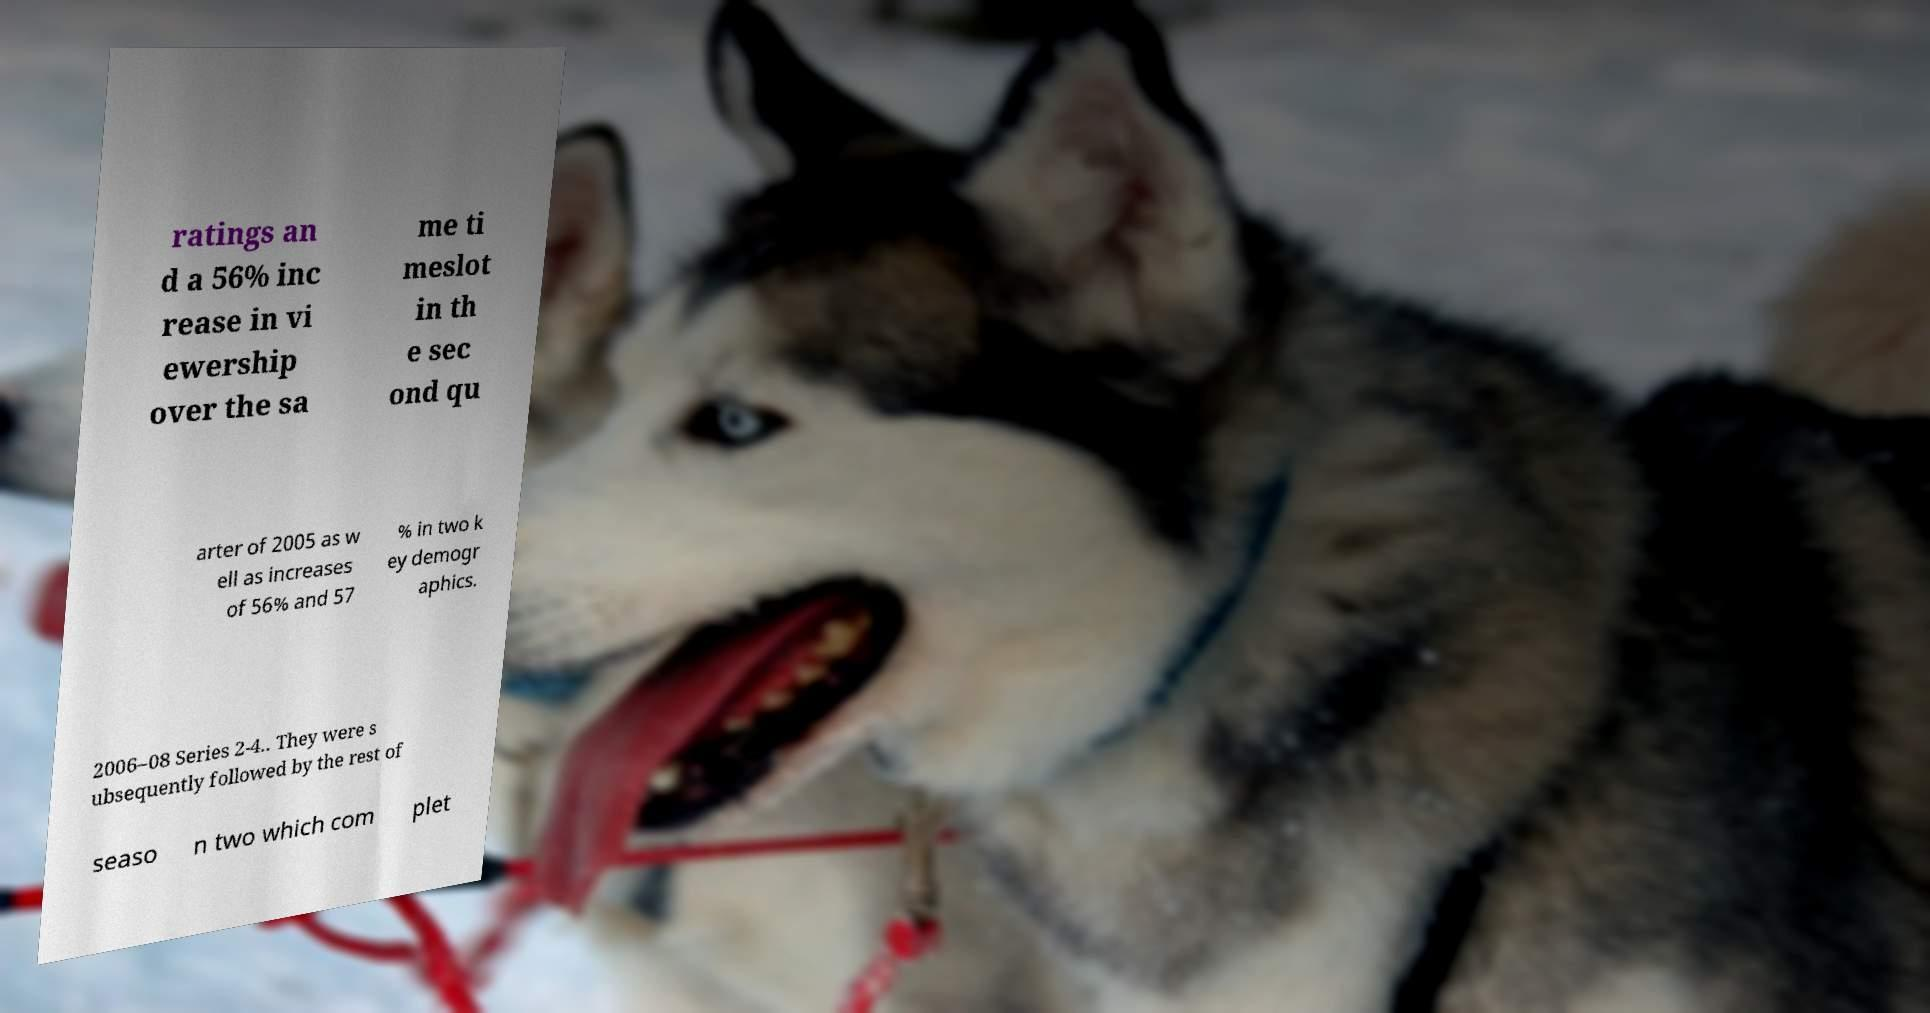Can you accurately transcribe the text from the provided image for me? ratings an d a 56% inc rease in vi ewership over the sa me ti meslot in th e sec ond qu arter of 2005 as w ell as increases of 56% and 57 % in two k ey demogr aphics. 2006–08 Series 2-4.. They were s ubsequently followed by the rest of seaso n two which com plet 